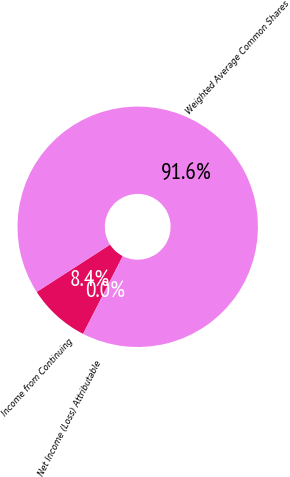Convert chart to OTSL. <chart><loc_0><loc_0><loc_500><loc_500><pie_chart><fcel>Income from Continuing<fcel>Net Income (Loss) Attributable<fcel>Weighted Average Common Shares<nl><fcel>8.38%<fcel>0.0%<fcel>91.62%<nl></chart> 